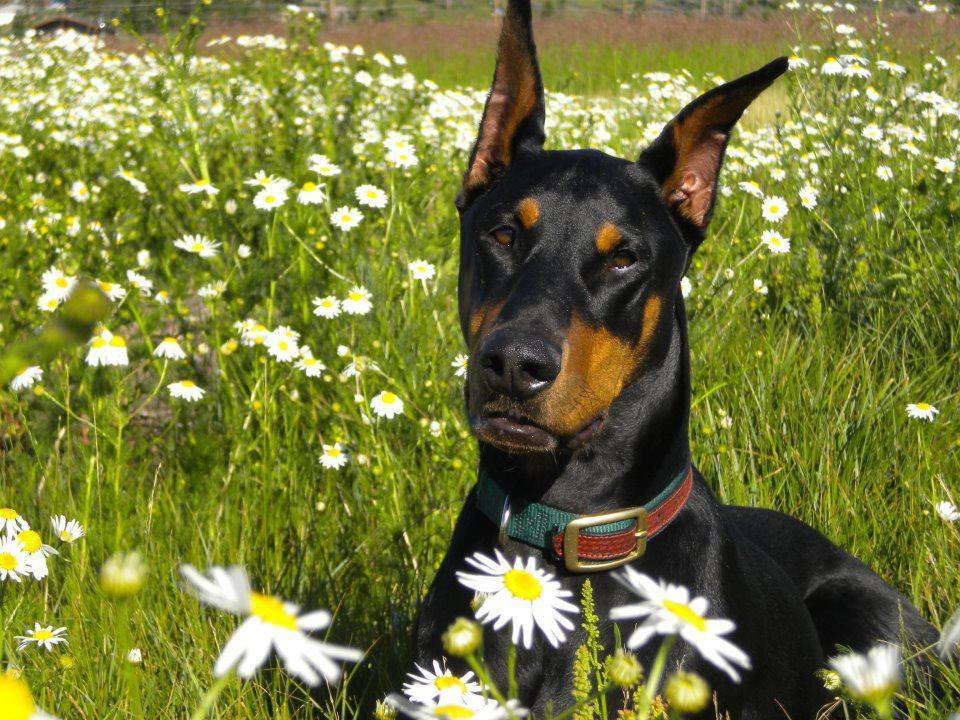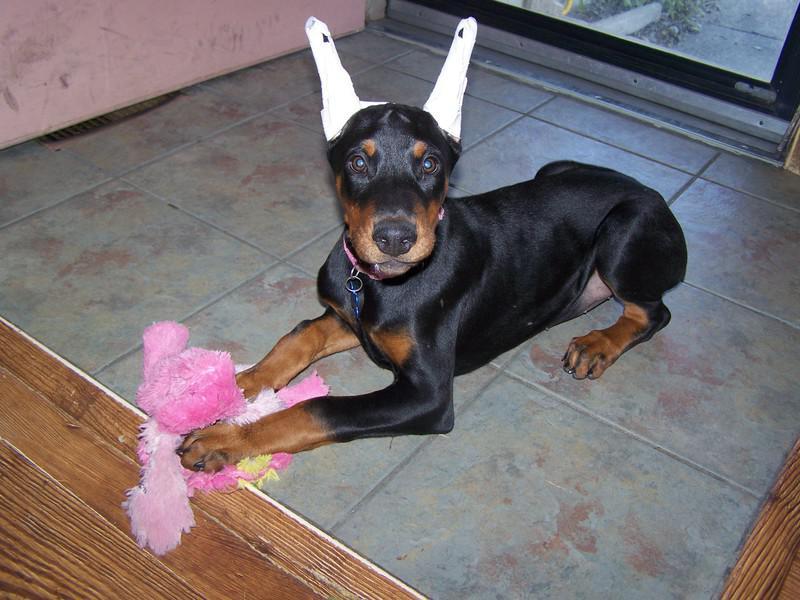The first image is the image on the left, the second image is the image on the right. Examine the images to the left and right. Is the description "There are at least three dogs in total." accurate? Answer yes or no. No. The first image is the image on the left, the second image is the image on the right. Analyze the images presented: Is the assertion "The combined images contain exactly two reclining dobermans with upright ears and faces angled forward so both eyes are visible." valid? Answer yes or no. Yes. 